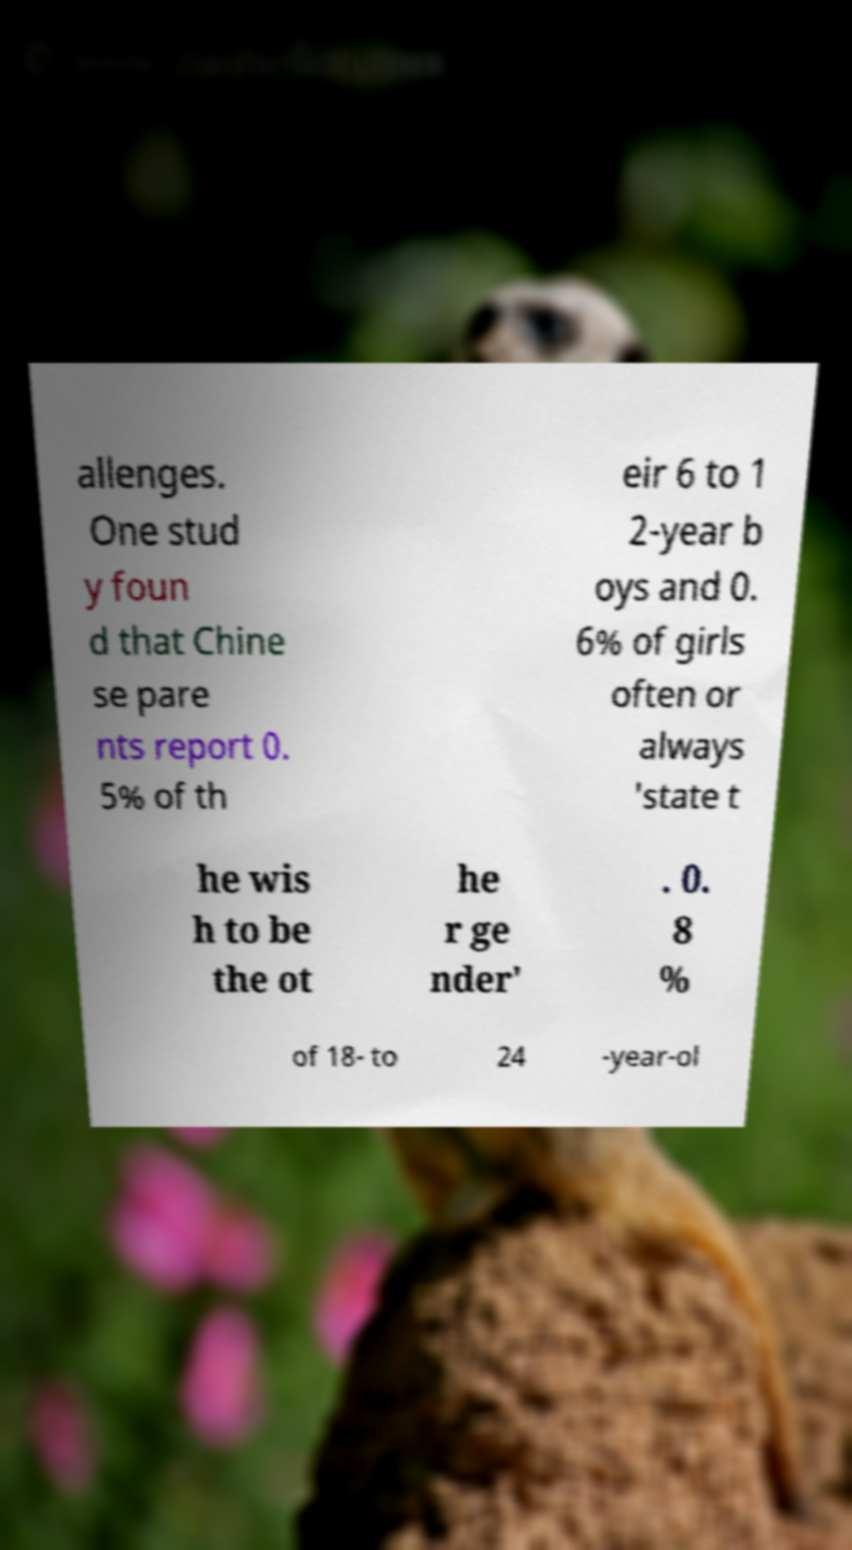I need the written content from this picture converted into text. Can you do that? allenges. One stud y foun d that Chine se pare nts report 0. 5% of th eir 6 to 1 2-year b oys and 0. 6% of girls often or always 'state t he wis h to be the ot he r ge nder' . 0. 8 % of 18- to 24 -year-ol 